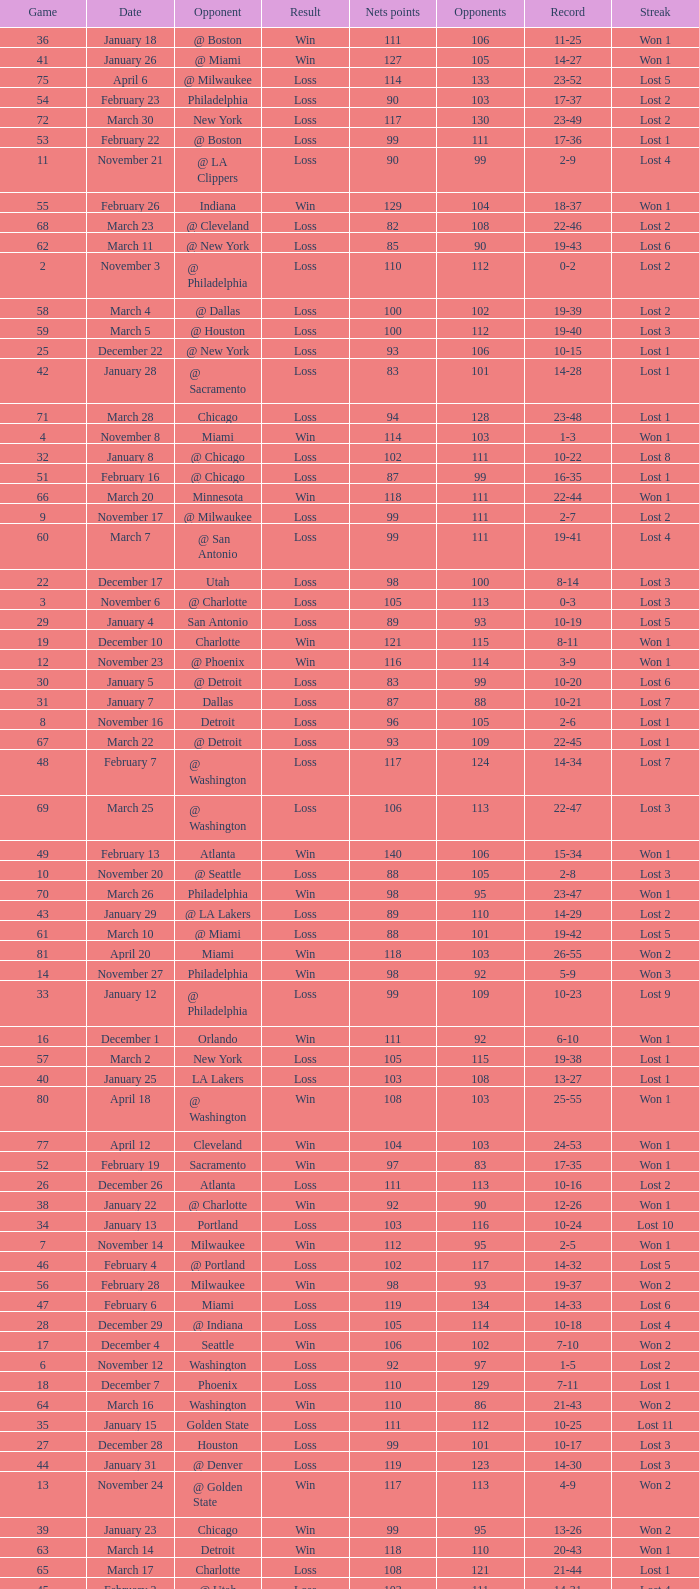In which game did the opponent score more than 103 and the record was 1-3? None. 